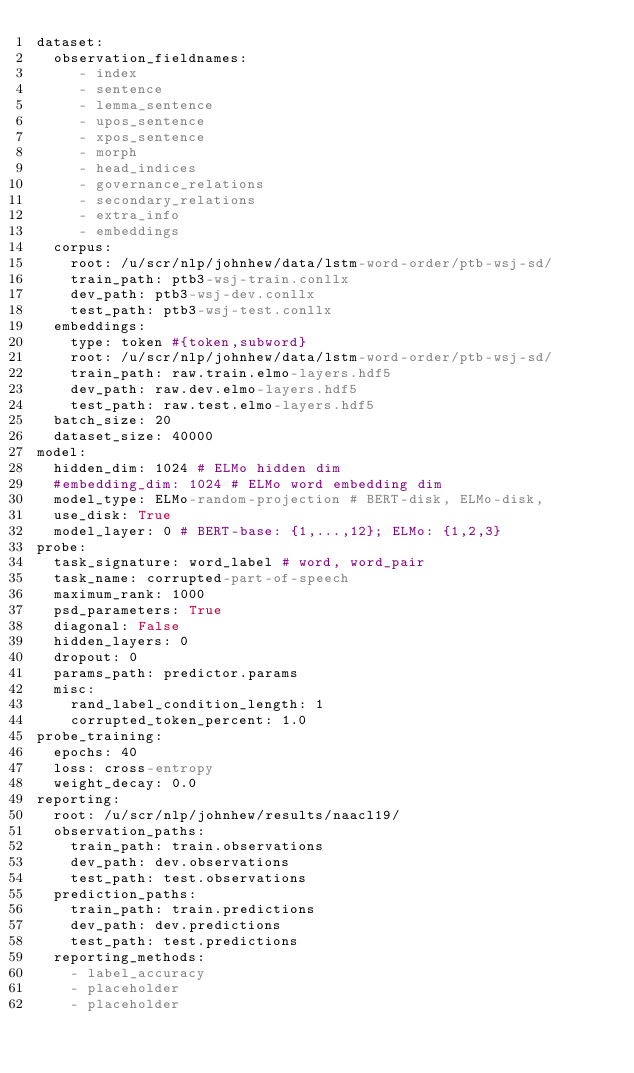<code> <loc_0><loc_0><loc_500><loc_500><_YAML_>dataset:
  observation_fieldnames:
     - index
     - sentence
     - lemma_sentence
     - upos_sentence
     - xpos_sentence
     - morph
     - head_indices
     - governance_relations
     - secondary_relations
     - extra_info
     - embeddings
  corpus:
    root: /u/scr/nlp/johnhew/data/lstm-word-order/ptb-wsj-sd/
    train_path: ptb3-wsj-train.conllx
    dev_path: ptb3-wsj-dev.conllx
    test_path: ptb3-wsj-test.conllx
  embeddings:
    type: token #{token,subword}
    root: /u/scr/nlp/johnhew/data/lstm-word-order/ptb-wsj-sd/
    train_path: raw.train.elmo-layers.hdf5
    dev_path: raw.dev.elmo-layers.hdf5
    test_path: raw.test.elmo-layers.hdf5
  batch_size: 20
  dataset_size: 40000
model:
  hidden_dim: 1024 # ELMo hidden dim
  #embedding_dim: 1024 # ELMo word embedding dim
  model_type: ELMo-random-projection # BERT-disk, ELMo-disk, 
  use_disk: True
  model_layer: 0 # BERT-base: {1,...,12}; ELMo: {1,2,3}
probe:
  task_signature: word_label # word, word_pair
  task_name: corrupted-part-of-speech
  maximum_rank: 1000
  psd_parameters: True
  diagonal: False
  hidden_layers: 0
  dropout: 0
  params_path: predictor.params
  misc:
    rand_label_condition_length: 1
    corrupted_token_percent: 1.0
probe_training:
  epochs: 40
  loss: cross-entropy
  weight_decay: 0.0
reporting:
  root: /u/scr/nlp/johnhew/results/naacl19/
  observation_paths:
    train_path: train.observations
    dev_path: dev.observations
    test_path: test.observations
  prediction_paths:
    train_path: train.predictions
    dev_path: dev.predictions
    test_path: test.predictions
  reporting_methods:
    - label_accuracy
    - placeholder
    - placeholder
</code> 